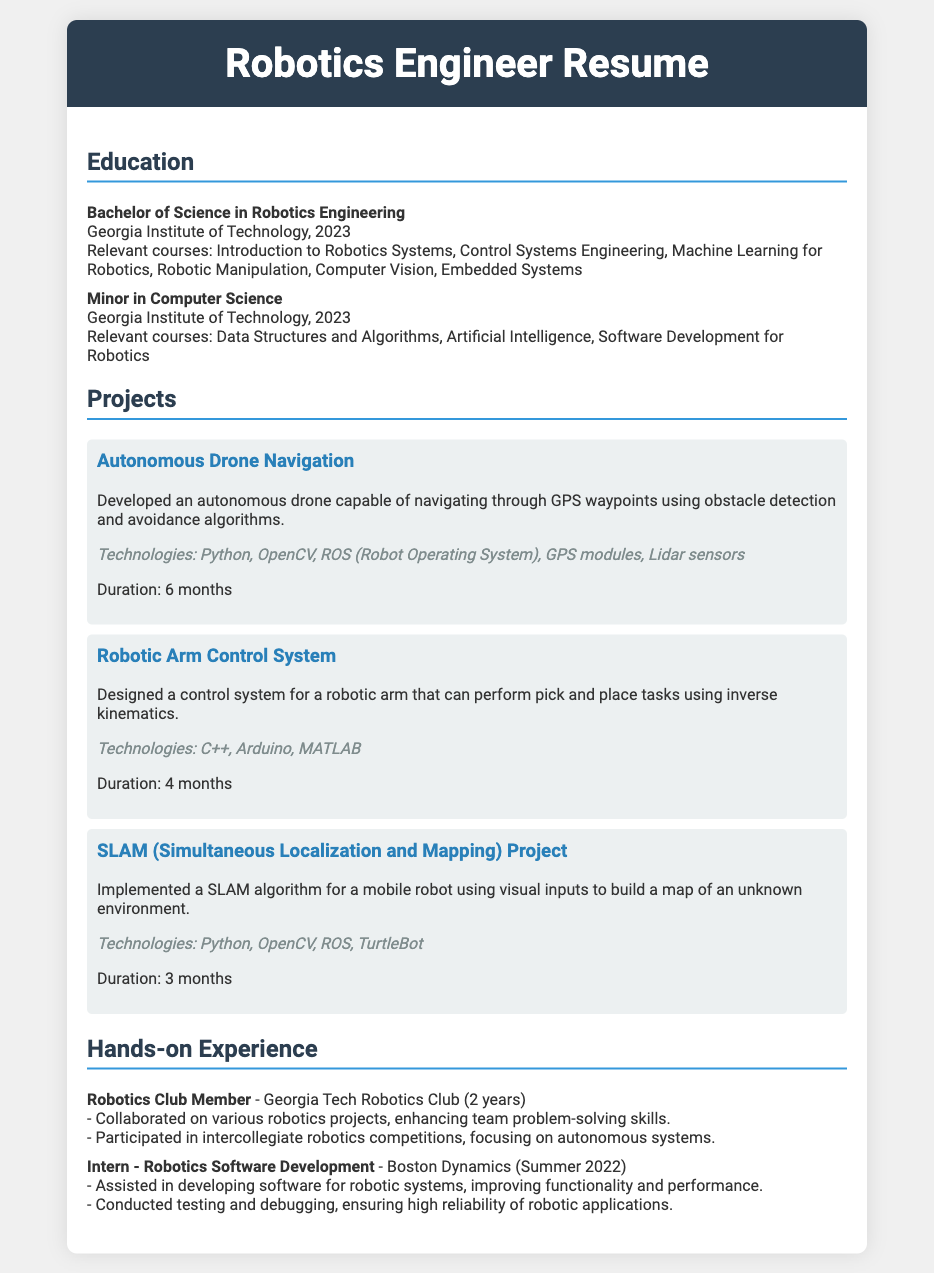what is the degree obtained? The degree obtained is specified in the education section of the document.
Answer: Bachelor of Science in Robotics Engineering what university did they attend? The university attended is mentioned in the education section.
Answer: Georgia Institute of Technology how many relevant courses are listed under the Robotics Engineering degree? The relevant courses are listed in the education section of the document. There are six courses mentioned.
Answer: 6 which project involved GPS waypoints? The projects section details various projects, and one specifically mentions GPS waypoints.
Answer: Autonomous Drone Navigation what technology was used in the Robotic Arm Control System? The technologies used for the Robotic Arm Control System are specified in the projects section.
Answer: C++, Arduino, MATLAB what was the duration of the SLAM project? The duration is mentioned in the description of the SLAM project within the projects section.
Answer: 3 months how many years of experience does the Robotics Club Member role entail? The hands-on experience section mentions the duration of the Robotics Club involvement.
Answer: 2 years who did they intern with as a Robotics Software Developer? The internship experience is documented in the hands-on experience section.
Answer: Boston Dynamics what type of competitions did the Robotics Club Member participate in? The hands-on experience section describes the type of activities participated in by the Robotics Club Member.
Answer: intercollegiate robotics competitions 